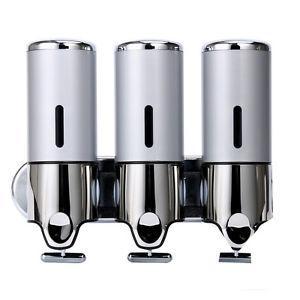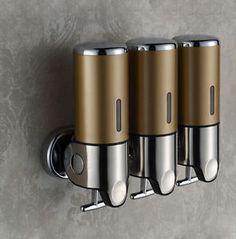The first image is the image on the left, the second image is the image on the right. Examine the images to the left and right. Is the description "The right hand image shows three dispensers that each have a different color of liquid inside of them." accurate? Answer yes or no. No. The first image is the image on the left, the second image is the image on the right. Considering the images on both sides, is "A three-in-one joined dispenser holds substances of three different colors that show through the transparent top portions." valid? Answer yes or no. No. 